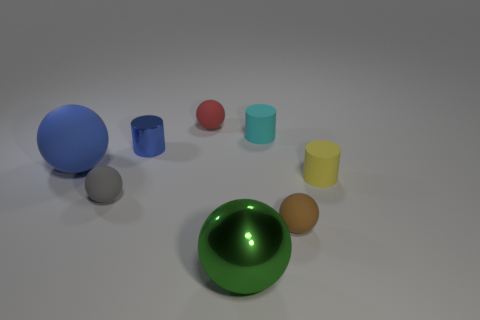Subtract all cyan matte cylinders. How many cylinders are left? 2 Subtract all gray balls. How many balls are left? 4 Subtract 1 balls. How many balls are left? 4 Subtract all cylinders. How many objects are left? 5 Add 2 yellow cylinders. How many objects exist? 10 Subtract all cyan spheres. Subtract all cyan cubes. How many spheres are left? 5 Add 1 small cyan objects. How many small cyan objects exist? 2 Subtract 1 brown balls. How many objects are left? 7 Subtract all big blue rubber things. Subtract all cyan cylinders. How many objects are left? 6 Add 8 gray objects. How many gray objects are left? 9 